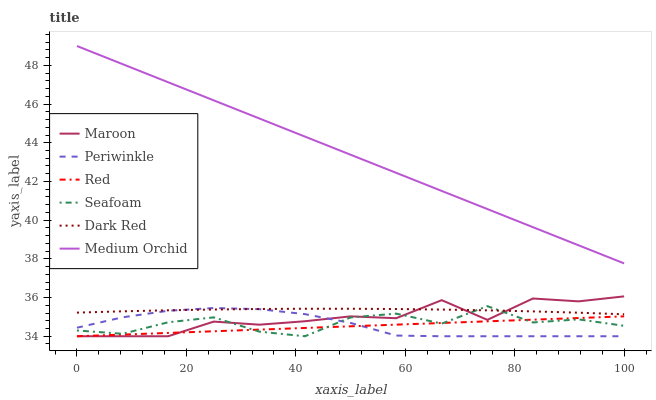Does Red have the minimum area under the curve?
Answer yes or no. Yes. Does Medium Orchid have the maximum area under the curve?
Answer yes or no. Yes. Does Seafoam have the minimum area under the curve?
Answer yes or no. No. Does Seafoam have the maximum area under the curve?
Answer yes or no. No. Is Red the smoothest?
Answer yes or no. Yes. Is Seafoam the roughest?
Answer yes or no. Yes. Is Medium Orchid the smoothest?
Answer yes or no. No. Is Medium Orchid the roughest?
Answer yes or no. No. Does Seafoam have the lowest value?
Answer yes or no. Yes. Does Medium Orchid have the lowest value?
Answer yes or no. No. Does Medium Orchid have the highest value?
Answer yes or no. Yes. Does Seafoam have the highest value?
Answer yes or no. No. Is Red less than Dark Red?
Answer yes or no. Yes. Is Medium Orchid greater than Dark Red?
Answer yes or no. Yes. Does Dark Red intersect Maroon?
Answer yes or no. Yes. Is Dark Red less than Maroon?
Answer yes or no. No. Is Dark Red greater than Maroon?
Answer yes or no. No. Does Red intersect Dark Red?
Answer yes or no. No. 